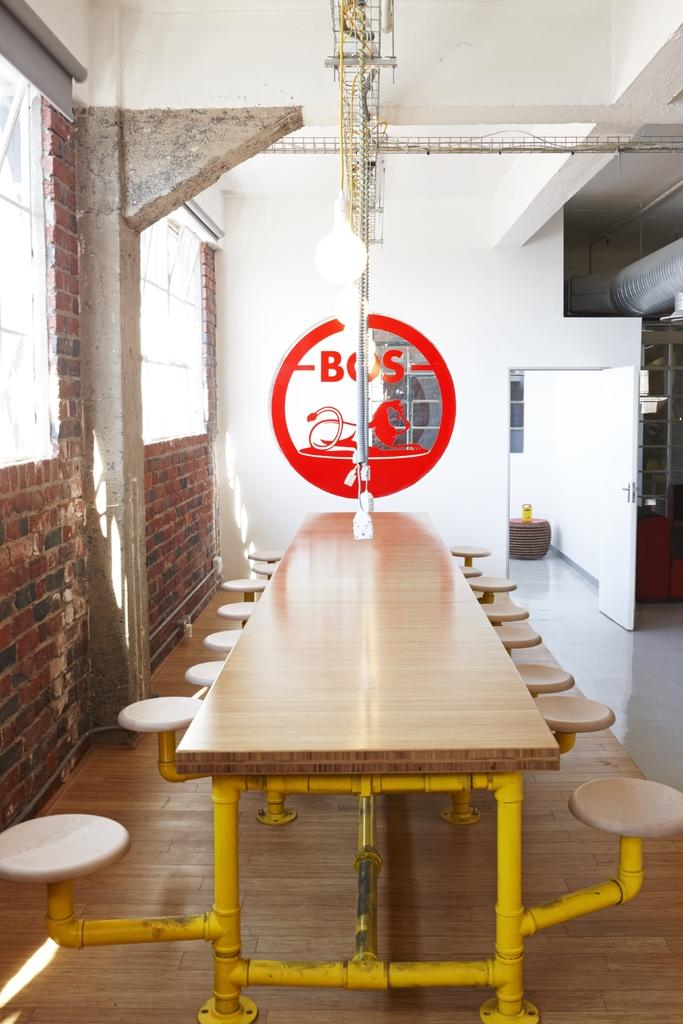What is the main piece of furniture in the center of the image? There is a table with attached stools in the center of the image. What can be seen in the background of the image? There is a wall and windows in the background of the image. Are there any other objects visible in the background? Yes, there are a few other objects in the background of the image. What type of locket is hanging from the wall in the image? There is no locket present in the image; only a wall and windows are visible in the background. Can you tell me how many members are in the band playing in the image? There is: There is no band present in the image; the focus is on the table with attached stools and the background. 